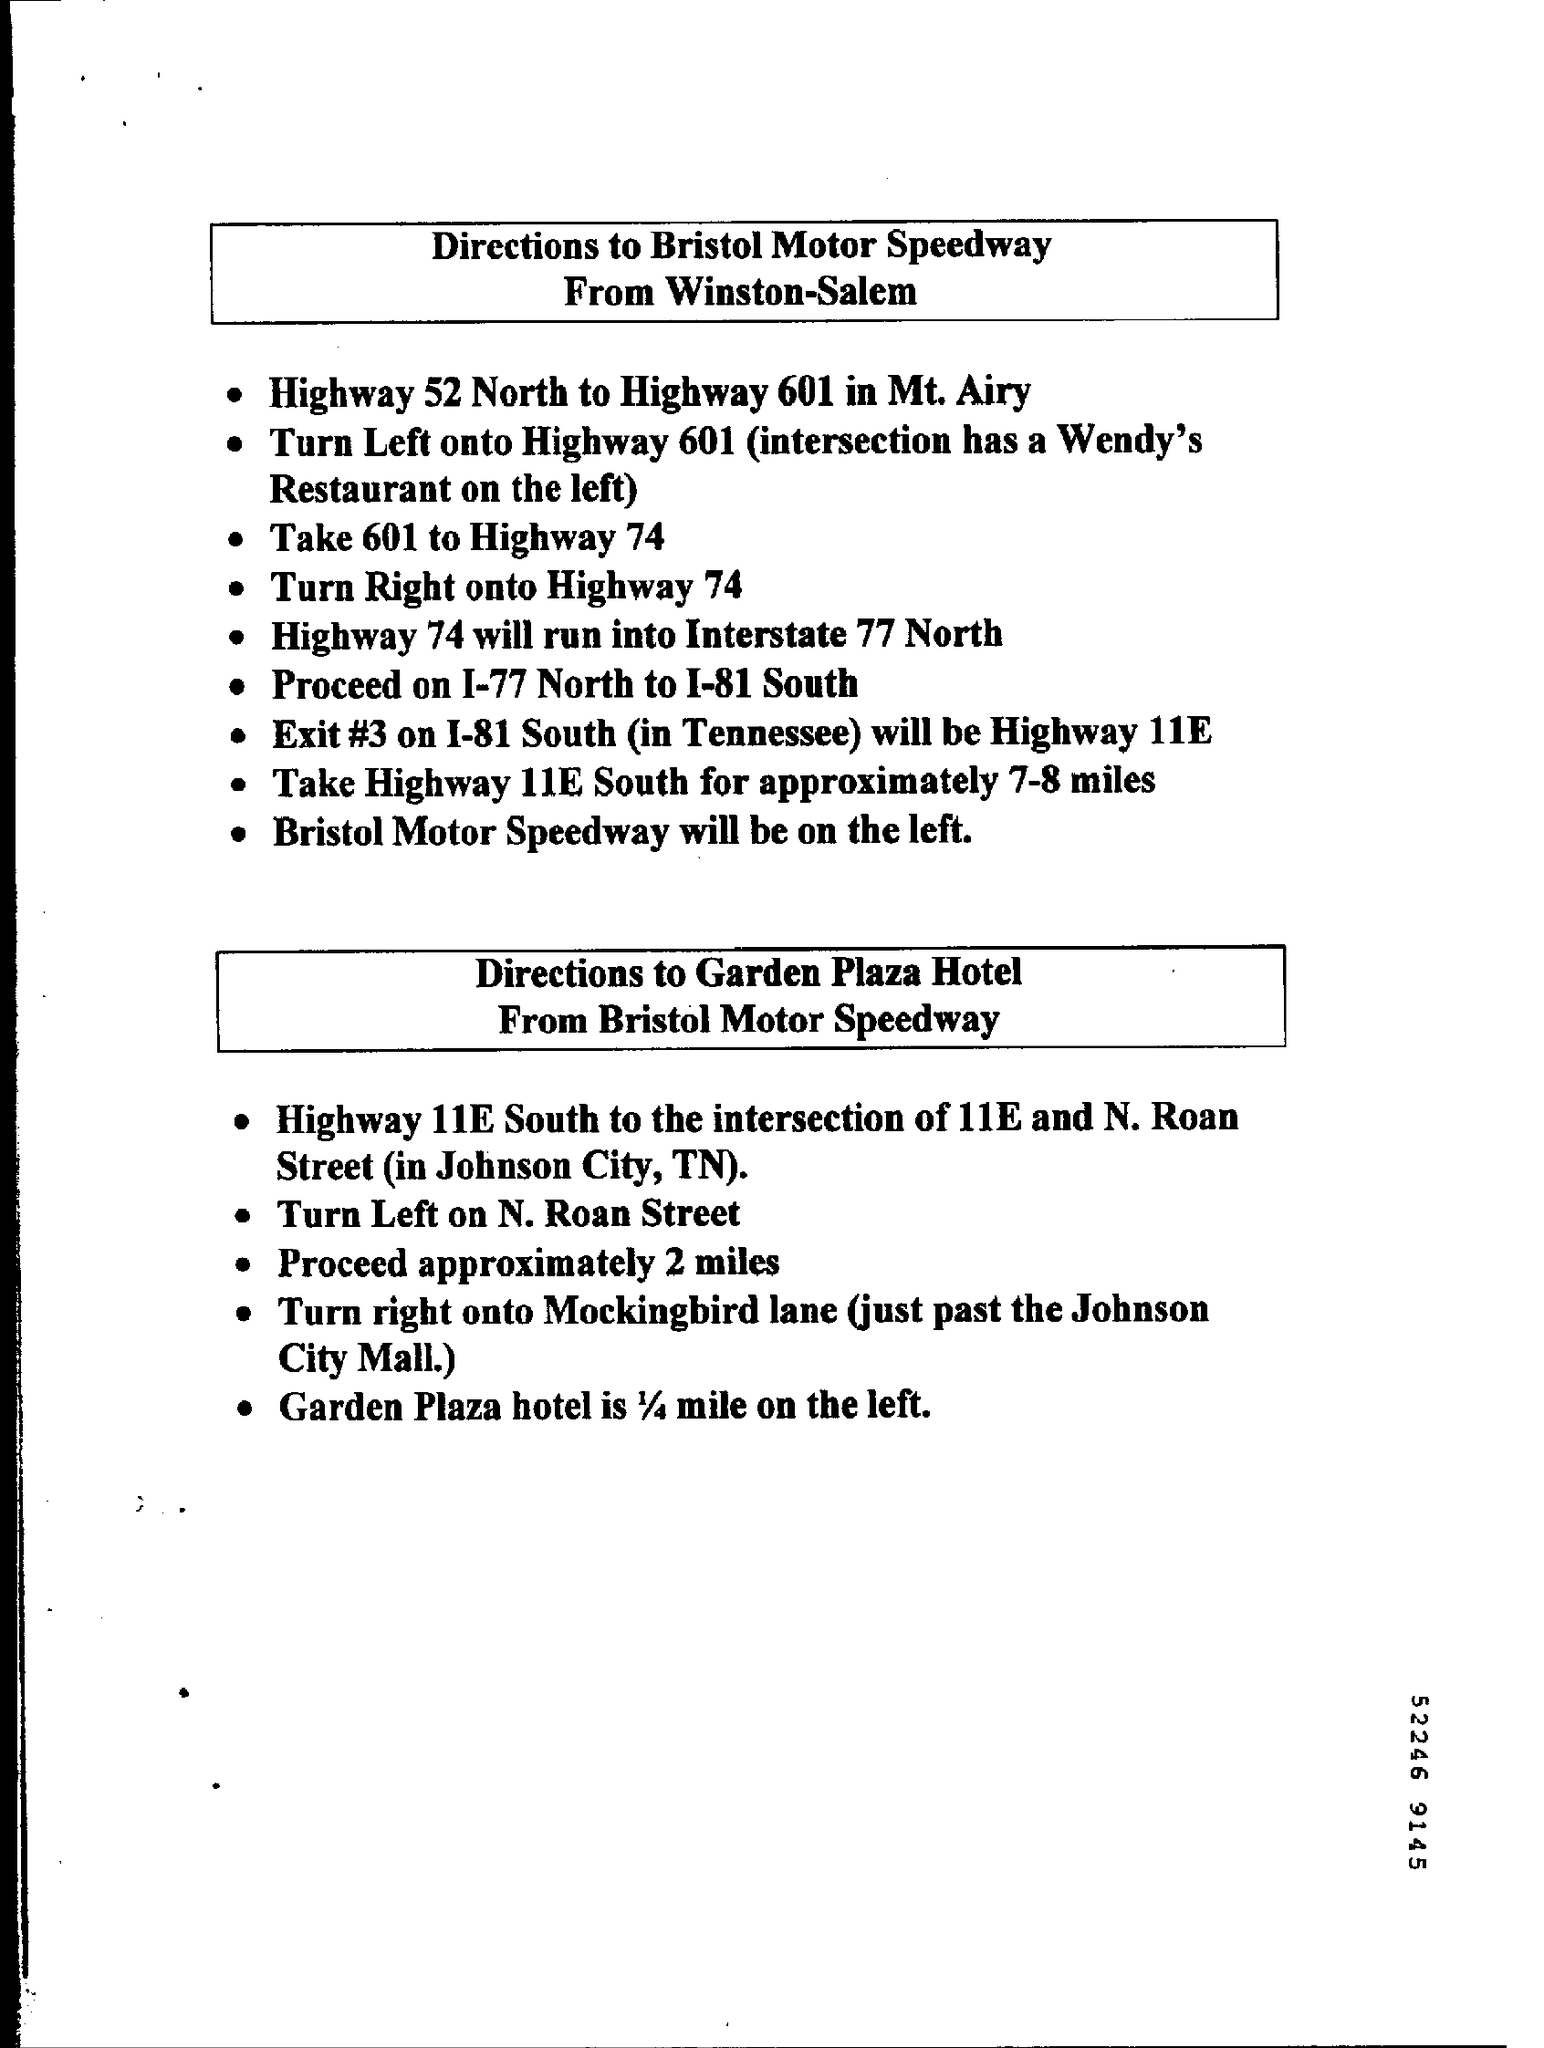Which number is at the bottom?
Provide a succinct answer. 52246 9145. What is written in the second box?
Provide a short and direct response. Directions to Garden Plaza Hotel From Bristol Motor Speedway. 